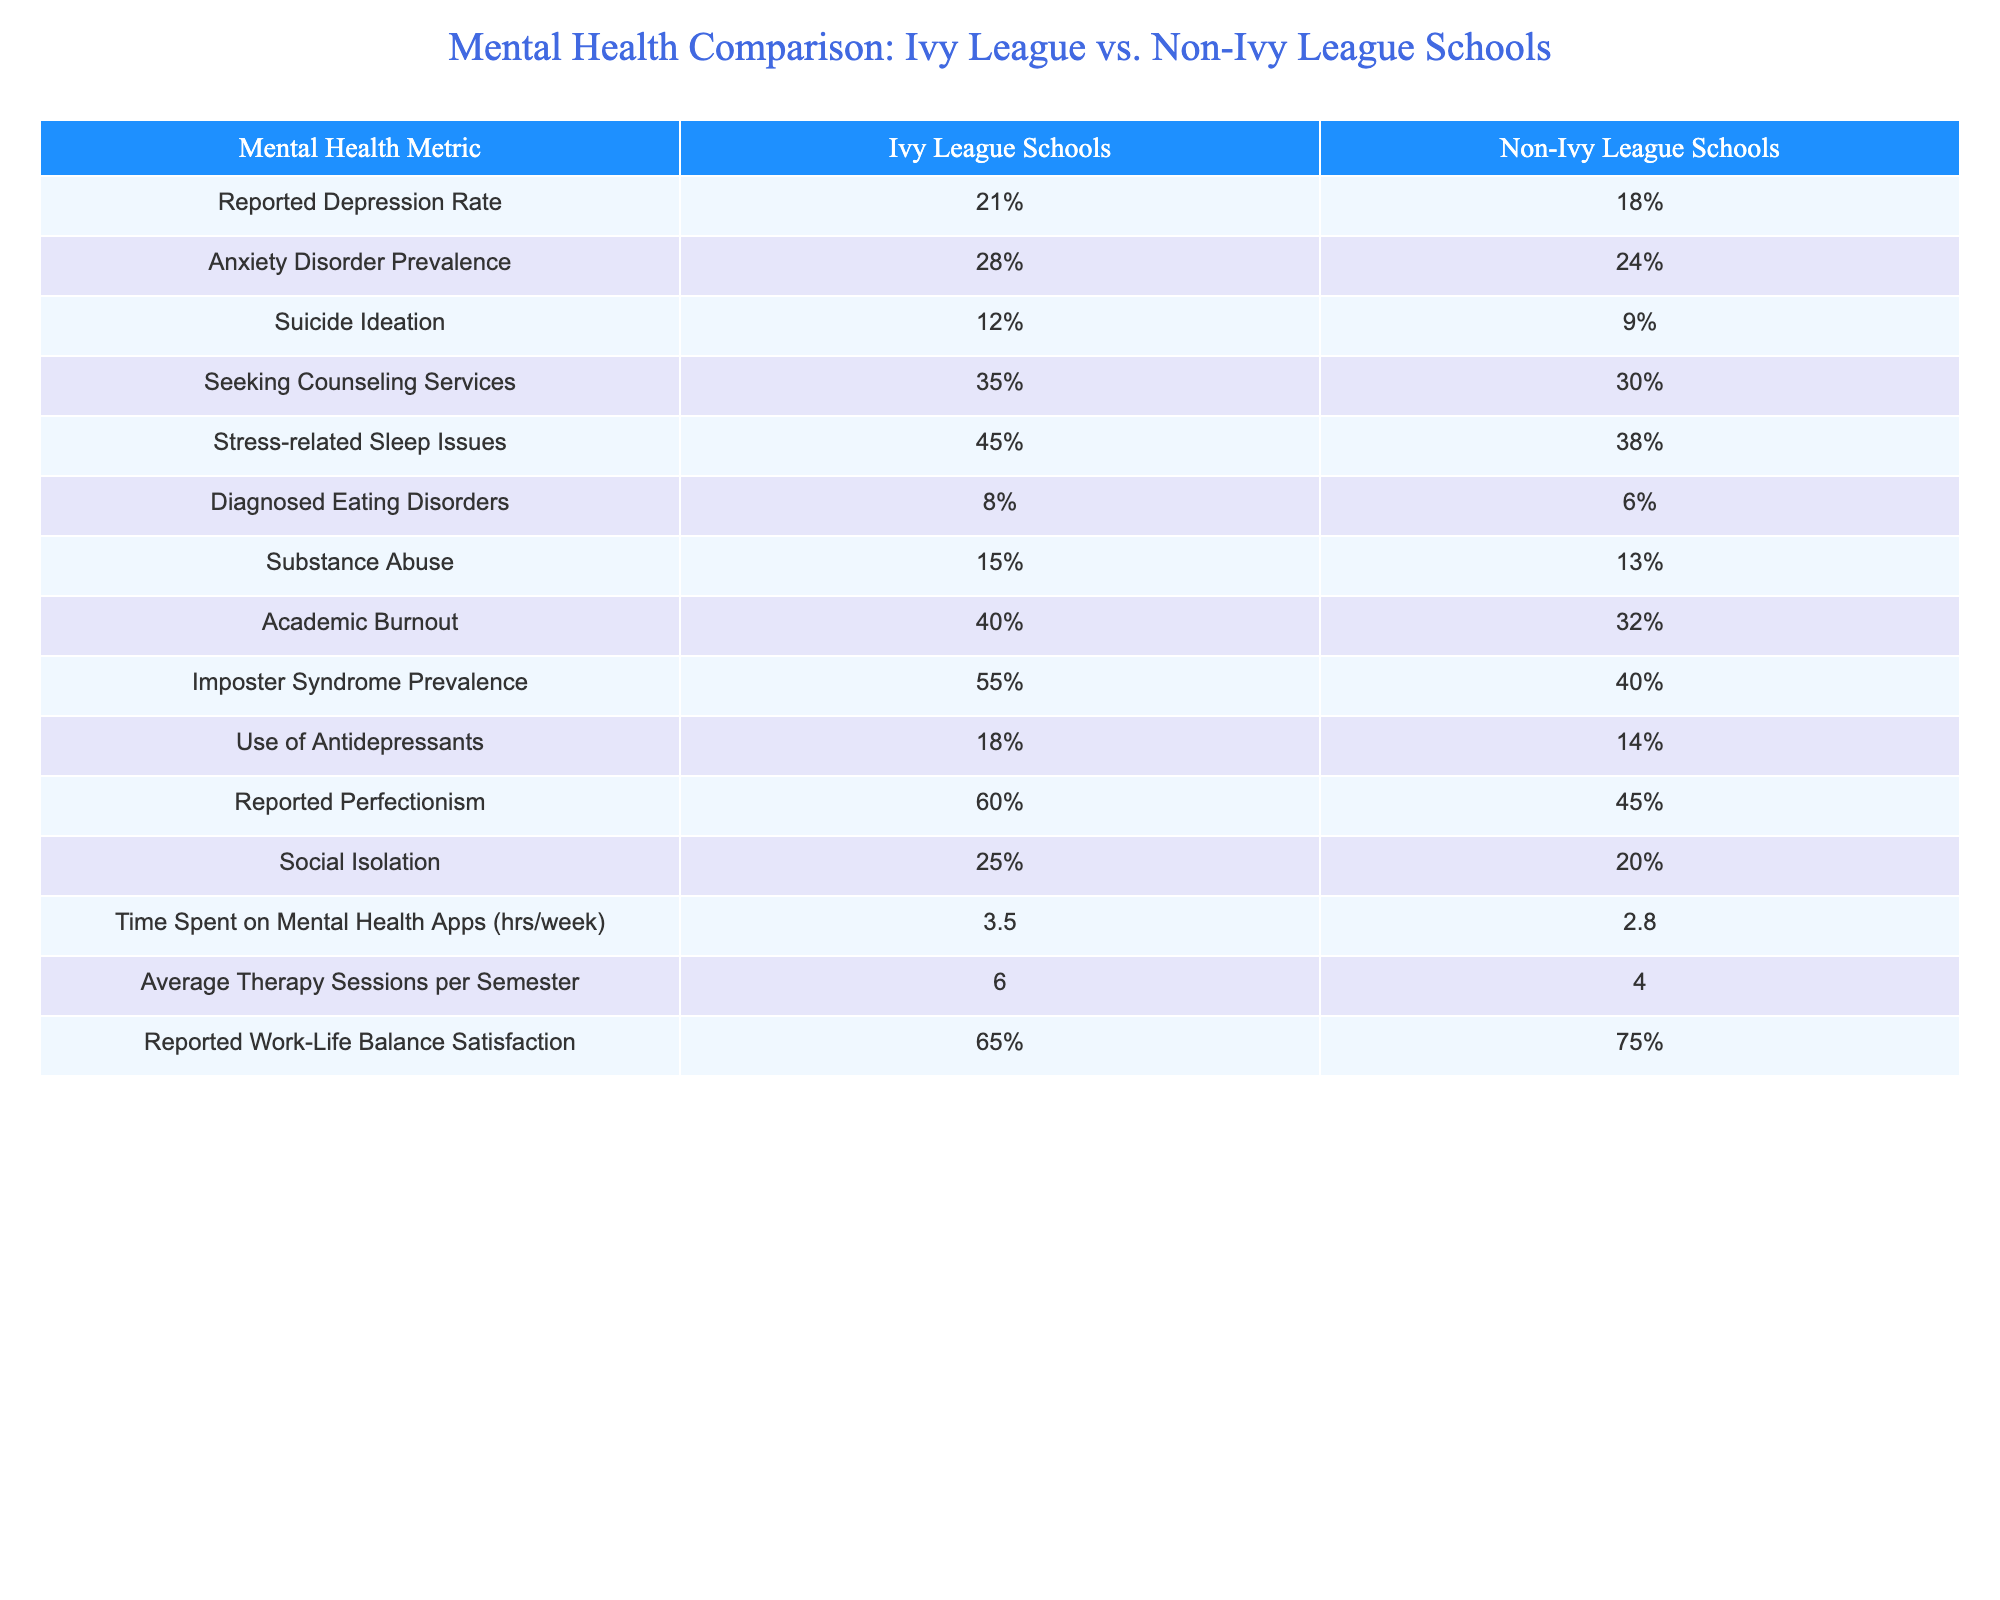What is the reported depression rate for Ivy League students? The reported depression rate for Ivy League students is found directly in the table under "Ivy League Schools" for the "Reported Depression Rate" metric, which states 21%.
Answer: 21% What percentage of Ivy League students seek counseling services compared to non-Ivy League students? The table lists 35% of Ivy League students seek counseling services compared to 30% for non-Ivy League students.
Answer: 35% for Ivy League and 30% for non-Ivy League Is the prevalence of anxiety disorders higher in Ivy League schools than in non-Ivy League schools? Yes, the table shows that the anxiety disorder prevalence is 28% in Ivy League schools, which is higher than the 24% in non-Ivy League schools.
Answer: Yes What is the difference in the percentage of students reporting social isolation between Ivy League and non-Ivy League schools? The reported social isolation rate for Ivy League students is 25%, and for non-Ivy League students it is 20%. The difference is calculated as 25% - 20% = 5%.
Answer: 5% What is the average number of therapy sessions per semester for students in Ivy League schools? The table indicates that Ivy League students have an average of 6 therapy sessions per semester. Thus, the answer is simply taken from the table value specified under "Average Therapy Sessions per Semester."
Answer: 6 Based on the data, do more Ivy League students report perfectionism than non-Ivy League students? Yes, the table indicates that 60% of Ivy League students report perfectionism, compared to 45% of non-Ivy League students, confirming a higher prevalence in Ivy League schools.
Answer: Yes What is the combined reported rate of diagnosed eating disorders and substance abuse for Ivy League students? The reported rates are 8% for diagnosed eating disorders and 15% for substance abuse in Ivy League students. Combining these values, we calculate: 8% + 15% = 23%.
Answer: 23% What percentage of Ivy League students report a satisfaction with their work-life balance? The table shows that 65% of Ivy League students report satisfaction with their work-life balance. This percentage is taken directly from the relevant row in the table.
Answer: 65% Which group has a higher rate of academic burnout, Ivy League or non-Ivy League students? The percentage of Ivy League students experiencing academic burnout is 40%, while for non-Ivy League students it is 32%. Therefore, Ivy League students have a higher rate of academic burnout.
Answer: Ivy League students What is the total percentage of Ivy League students who reported either anxiety disorder prevalence or imposter syndrome prevalence? The rates are 28% for anxiety disorders and 55% for imposter syndrome among Ivy League students. To find the total, we add both percentages: 28% + 55% = 83%.
Answer: 83% 